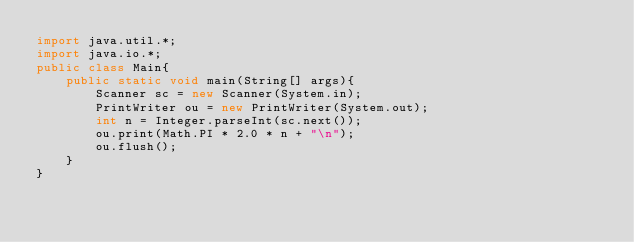<code> <loc_0><loc_0><loc_500><loc_500><_Java_>import java.util.*;
import java.io.*;
public class Main{
    public static void main(String[] args){
		Scanner sc = new Scanner(System.in);
		PrintWriter ou = new PrintWriter(System.out);
		int n = Integer.parseInt(sc.next());
		ou.print(Math.PI * 2.0 * n + "\n");
		ou.flush();
    }
}</code> 